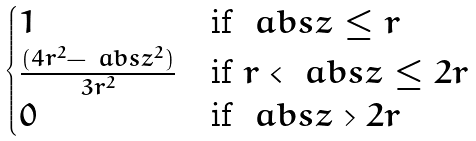Convert formula to latex. <formula><loc_0><loc_0><loc_500><loc_500>\begin{cases} 1 & \text {if\ } \ a b s { z } \leq r \\ \frac { ( 4 r ^ { 2 } - \ a b s { z } ^ { 2 } ) } { 3 r ^ { 2 } } & \text {if\ } r < \ a b s { z } \leq 2 r \\ 0 & \text {if\ } \ a b s { z } > 2 r \end{cases}</formula> 